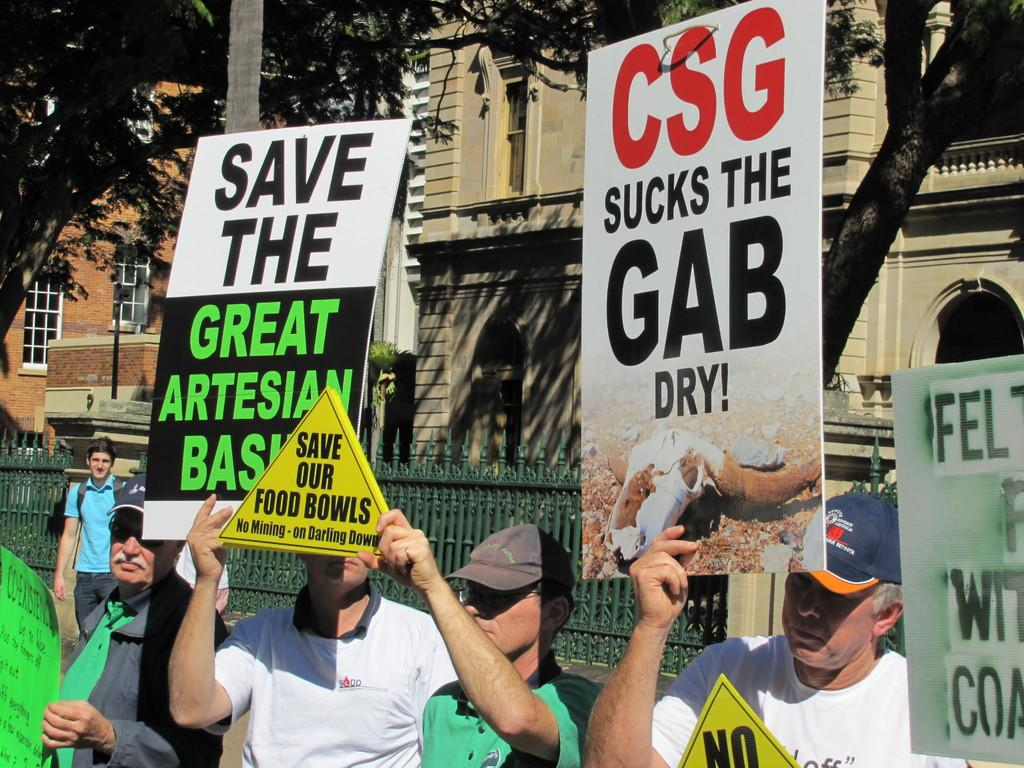What are the people in the image doing? The people in the image are holding placards. What is located in front of the people in the image? There is a metal fence in the image. What can be seen in the distance behind the people in the image? There are buildings and trees in the background of the image. What type of song is being sung by the dolls in the image? There are no dolls present in the image, and therefore no song can be heard or seen. 